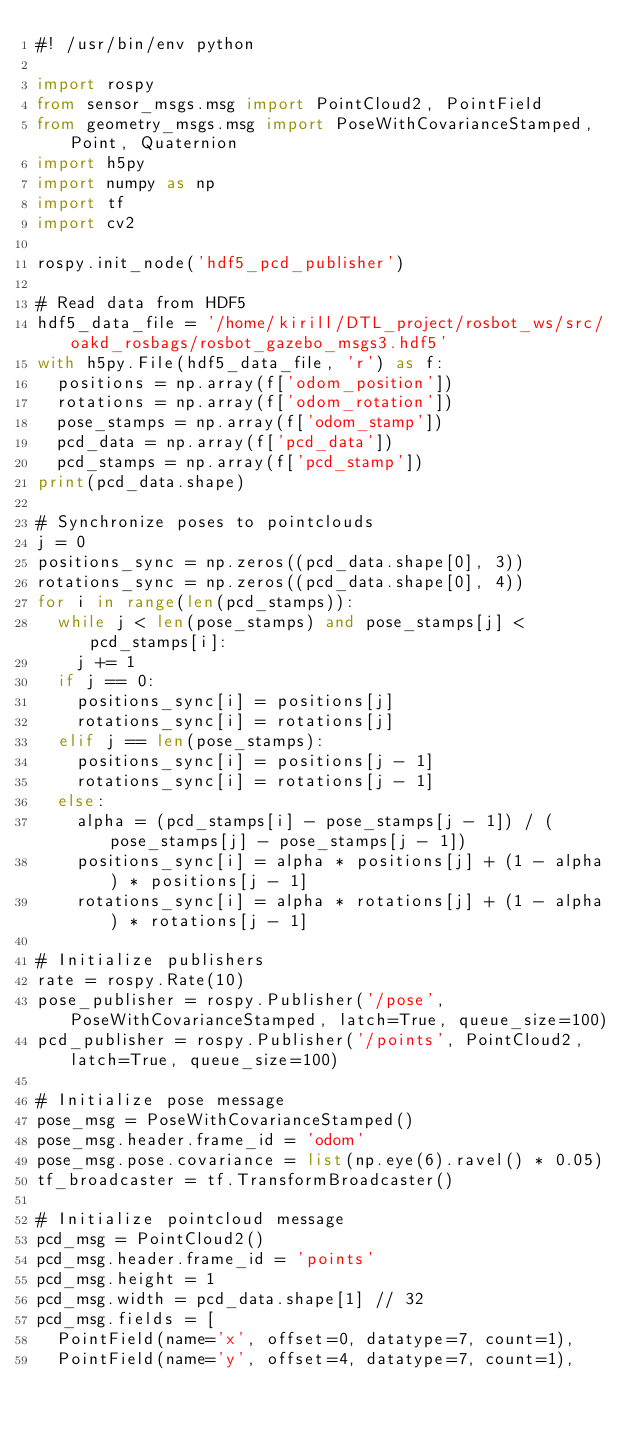Convert code to text. <code><loc_0><loc_0><loc_500><loc_500><_Python_>#! /usr/bin/env python

import rospy
from sensor_msgs.msg import PointCloud2, PointField
from geometry_msgs.msg import PoseWithCovarianceStamped, Point, Quaternion
import h5py
import numpy as np
import tf
import cv2

rospy.init_node('hdf5_pcd_publisher')

# Read data from HDF5
hdf5_data_file = '/home/kirill/DTL_project/rosbot_ws/src/oakd_rosbags/rosbot_gazebo_msgs3.hdf5'
with h5py.File(hdf5_data_file, 'r') as f:
	positions = np.array(f['odom_position'])
	rotations = np.array(f['odom_rotation'])
	pose_stamps = np.array(f['odom_stamp'])
	pcd_data = np.array(f['pcd_data'])
	pcd_stamps = np.array(f['pcd_stamp'])
print(pcd_data.shape)

# Synchronize poses to pointclouds
j = 0
positions_sync = np.zeros((pcd_data.shape[0], 3))
rotations_sync = np.zeros((pcd_data.shape[0], 4))
for i in range(len(pcd_stamps)):
	while j < len(pose_stamps) and pose_stamps[j] < pcd_stamps[i]:
		j += 1
	if j == 0:
		positions_sync[i] = positions[j]
		rotations_sync[i] = rotations[j]
	elif j == len(pose_stamps):
		positions_sync[i] = positions[j - 1]
		rotations_sync[i] = rotations[j - 1]
	else:
		alpha = (pcd_stamps[i] - pose_stamps[j - 1]) / (pose_stamps[j] - pose_stamps[j - 1])
		positions_sync[i] = alpha * positions[j] + (1 - alpha) * positions[j - 1]
		rotations_sync[i] = alpha * rotations[j] + (1 - alpha) * rotations[j - 1]

# Initialize publishers
rate = rospy.Rate(10)
pose_publisher = rospy.Publisher('/pose', PoseWithCovarianceStamped, latch=True, queue_size=100)
pcd_publisher = rospy.Publisher('/points', PointCloud2, latch=True, queue_size=100)

# Initialize pose message
pose_msg = PoseWithCovarianceStamped()
pose_msg.header.frame_id = 'odom'
pose_msg.pose.covariance = list(np.eye(6).ravel() * 0.05)
tf_broadcaster = tf.TransformBroadcaster()

# Initialize pointcloud message
pcd_msg = PointCloud2()
pcd_msg.header.frame_id = 'points'
pcd_msg.height = 1
pcd_msg.width = pcd_data.shape[1] // 32
pcd_msg.fields = [
	PointField(name='x', offset=0, datatype=7, count=1),
	PointField(name='y', offset=4, datatype=7, count=1),</code> 